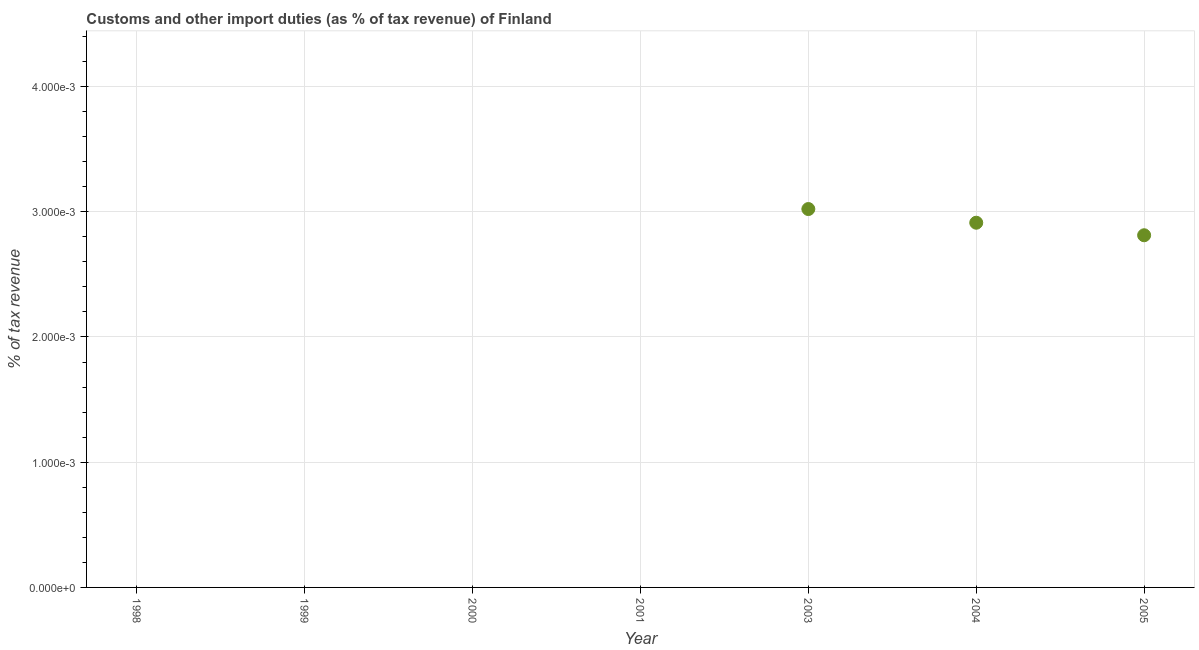What is the customs and other import duties in 2004?
Provide a succinct answer. 0. Across all years, what is the maximum customs and other import duties?
Make the answer very short. 0. Across all years, what is the minimum customs and other import duties?
Ensure brevity in your answer.  0. In which year was the customs and other import duties maximum?
Offer a terse response. 2003. What is the sum of the customs and other import duties?
Your answer should be very brief. 0.01. What is the difference between the customs and other import duties in 2004 and 2005?
Offer a very short reply. 0. What is the average customs and other import duties per year?
Your answer should be very brief. 0. In how many years, is the customs and other import duties greater than 0.0042 %?
Offer a very short reply. 0. Is the customs and other import duties in 2004 less than that in 2005?
Keep it short and to the point. No. What is the difference between the highest and the second highest customs and other import duties?
Offer a terse response. 0. What is the difference between the highest and the lowest customs and other import duties?
Your answer should be very brief. 0. In how many years, is the customs and other import duties greater than the average customs and other import duties taken over all years?
Offer a very short reply. 3. Does the customs and other import duties monotonically increase over the years?
Ensure brevity in your answer.  No. How many dotlines are there?
Your answer should be very brief. 1. How many years are there in the graph?
Offer a very short reply. 7. What is the difference between two consecutive major ticks on the Y-axis?
Provide a short and direct response. 0. Are the values on the major ticks of Y-axis written in scientific E-notation?
Ensure brevity in your answer.  Yes. Does the graph contain any zero values?
Provide a short and direct response. Yes. What is the title of the graph?
Your response must be concise. Customs and other import duties (as % of tax revenue) of Finland. What is the label or title of the Y-axis?
Give a very brief answer. % of tax revenue. What is the % of tax revenue in 2001?
Keep it short and to the point. 0. What is the % of tax revenue in 2003?
Your answer should be very brief. 0. What is the % of tax revenue in 2004?
Your answer should be very brief. 0. What is the % of tax revenue in 2005?
Keep it short and to the point. 0. What is the difference between the % of tax revenue in 2003 and 2004?
Make the answer very short. 0. What is the difference between the % of tax revenue in 2003 and 2005?
Offer a very short reply. 0. What is the ratio of the % of tax revenue in 2003 to that in 2004?
Give a very brief answer. 1.04. What is the ratio of the % of tax revenue in 2003 to that in 2005?
Offer a terse response. 1.07. What is the ratio of the % of tax revenue in 2004 to that in 2005?
Offer a very short reply. 1.04. 